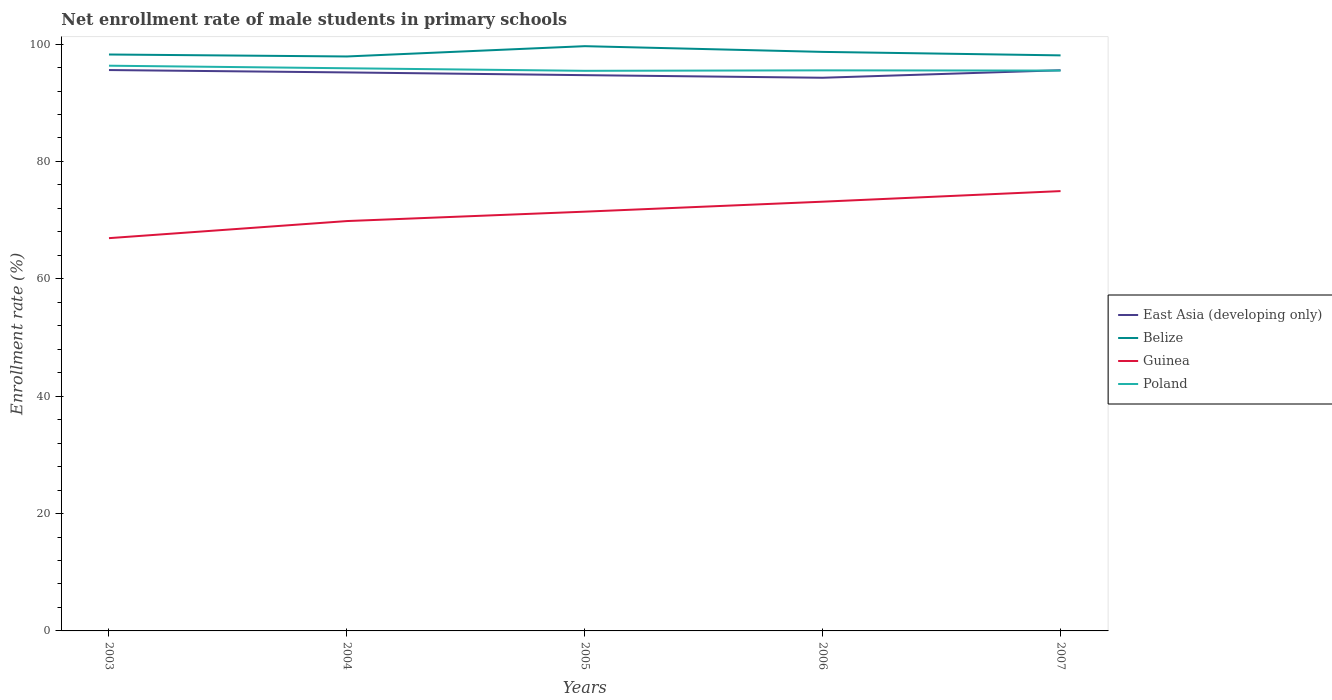How many different coloured lines are there?
Your answer should be compact. 4. Does the line corresponding to East Asia (developing only) intersect with the line corresponding to Poland?
Your answer should be compact. Yes. Is the number of lines equal to the number of legend labels?
Keep it short and to the point. Yes. Across all years, what is the maximum net enrollment rate of male students in primary schools in Poland?
Make the answer very short. 95.44. In which year was the net enrollment rate of male students in primary schools in Guinea maximum?
Keep it short and to the point. 2003. What is the total net enrollment rate of male students in primary schools in Poland in the graph?
Make the answer very short. 0.83. What is the difference between the highest and the second highest net enrollment rate of male students in primary schools in Belize?
Provide a succinct answer. 1.75. How many lines are there?
Provide a short and direct response. 4. What is the difference between two consecutive major ticks on the Y-axis?
Offer a terse response. 20. Does the graph contain any zero values?
Ensure brevity in your answer.  No. Does the graph contain grids?
Your response must be concise. No. How many legend labels are there?
Provide a short and direct response. 4. What is the title of the graph?
Give a very brief answer. Net enrollment rate of male students in primary schools. What is the label or title of the Y-axis?
Offer a terse response. Enrollment rate (%). What is the Enrollment rate (%) of East Asia (developing only) in 2003?
Offer a terse response. 95.57. What is the Enrollment rate (%) in Belize in 2003?
Offer a very short reply. 98.22. What is the Enrollment rate (%) of Guinea in 2003?
Your answer should be very brief. 66.93. What is the Enrollment rate (%) of Poland in 2003?
Provide a succinct answer. 96.31. What is the Enrollment rate (%) in East Asia (developing only) in 2004?
Provide a short and direct response. 95.17. What is the Enrollment rate (%) of Belize in 2004?
Give a very brief answer. 97.89. What is the Enrollment rate (%) of Guinea in 2004?
Provide a short and direct response. 69.84. What is the Enrollment rate (%) in Poland in 2004?
Provide a succinct answer. 95.88. What is the Enrollment rate (%) of East Asia (developing only) in 2005?
Offer a very short reply. 94.7. What is the Enrollment rate (%) in Belize in 2005?
Provide a succinct answer. 99.64. What is the Enrollment rate (%) in Guinea in 2005?
Give a very brief answer. 71.44. What is the Enrollment rate (%) of Poland in 2005?
Your answer should be compact. 95.44. What is the Enrollment rate (%) in East Asia (developing only) in 2006?
Provide a succinct answer. 94.26. What is the Enrollment rate (%) of Belize in 2006?
Your answer should be compact. 98.67. What is the Enrollment rate (%) of Guinea in 2006?
Offer a very short reply. 73.14. What is the Enrollment rate (%) of Poland in 2006?
Provide a succinct answer. 95.52. What is the Enrollment rate (%) of East Asia (developing only) in 2007?
Your answer should be very brief. 95.54. What is the Enrollment rate (%) in Belize in 2007?
Offer a terse response. 98.07. What is the Enrollment rate (%) in Guinea in 2007?
Provide a succinct answer. 74.94. What is the Enrollment rate (%) of Poland in 2007?
Your answer should be compact. 95.48. Across all years, what is the maximum Enrollment rate (%) in East Asia (developing only)?
Make the answer very short. 95.57. Across all years, what is the maximum Enrollment rate (%) of Belize?
Give a very brief answer. 99.64. Across all years, what is the maximum Enrollment rate (%) of Guinea?
Offer a terse response. 74.94. Across all years, what is the maximum Enrollment rate (%) in Poland?
Your response must be concise. 96.31. Across all years, what is the minimum Enrollment rate (%) in East Asia (developing only)?
Ensure brevity in your answer.  94.26. Across all years, what is the minimum Enrollment rate (%) of Belize?
Your response must be concise. 97.89. Across all years, what is the minimum Enrollment rate (%) of Guinea?
Keep it short and to the point. 66.93. Across all years, what is the minimum Enrollment rate (%) in Poland?
Keep it short and to the point. 95.44. What is the total Enrollment rate (%) in East Asia (developing only) in the graph?
Ensure brevity in your answer.  475.24. What is the total Enrollment rate (%) in Belize in the graph?
Offer a terse response. 492.49. What is the total Enrollment rate (%) of Guinea in the graph?
Provide a short and direct response. 356.3. What is the total Enrollment rate (%) in Poland in the graph?
Make the answer very short. 478.64. What is the difference between the Enrollment rate (%) in East Asia (developing only) in 2003 and that in 2004?
Provide a succinct answer. 0.41. What is the difference between the Enrollment rate (%) of Belize in 2003 and that in 2004?
Make the answer very short. 0.34. What is the difference between the Enrollment rate (%) in Guinea in 2003 and that in 2004?
Offer a terse response. -2.91. What is the difference between the Enrollment rate (%) of Poland in 2003 and that in 2004?
Your answer should be very brief. 0.44. What is the difference between the Enrollment rate (%) of East Asia (developing only) in 2003 and that in 2005?
Offer a very short reply. 0.87. What is the difference between the Enrollment rate (%) in Belize in 2003 and that in 2005?
Ensure brevity in your answer.  -1.42. What is the difference between the Enrollment rate (%) in Guinea in 2003 and that in 2005?
Your answer should be very brief. -4.51. What is the difference between the Enrollment rate (%) of Poland in 2003 and that in 2005?
Keep it short and to the point. 0.87. What is the difference between the Enrollment rate (%) of East Asia (developing only) in 2003 and that in 2006?
Provide a short and direct response. 1.31. What is the difference between the Enrollment rate (%) in Belize in 2003 and that in 2006?
Your response must be concise. -0.44. What is the difference between the Enrollment rate (%) of Guinea in 2003 and that in 2006?
Keep it short and to the point. -6.21. What is the difference between the Enrollment rate (%) of Poland in 2003 and that in 2006?
Provide a succinct answer. 0.79. What is the difference between the Enrollment rate (%) of East Asia (developing only) in 2003 and that in 2007?
Keep it short and to the point. 0.04. What is the difference between the Enrollment rate (%) in Belize in 2003 and that in 2007?
Make the answer very short. 0.15. What is the difference between the Enrollment rate (%) in Guinea in 2003 and that in 2007?
Offer a very short reply. -8.02. What is the difference between the Enrollment rate (%) in Poland in 2003 and that in 2007?
Offer a very short reply. 0.83. What is the difference between the Enrollment rate (%) in East Asia (developing only) in 2004 and that in 2005?
Keep it short and to the point. 0.47. What is the difference between the Enrollment rate (%) in Belize in 2004 and that in 2005?
Your answer should be compact. -1.75. What is the difference between the Enrollment rate (%) of Guinea in 2004 and that in 2005?
Your answer should be very brief. -1.6. What is the difference between the Enrollment rate (%) of Poland in 2004 and that in 2005?
Provide a short and direct response. 0.43. What is the difference between the Enrollment rate (%) in East Asia (developing only) in 2004 and that in 2006?
Provide a succinct answer. 0.91. What is the difference between the Enrollment rate (%) of Belize in 2004 and that in 2006?
Offer a very short reply. -0.78. What is the difference between the Enrollment rate (%) in Guinea in 2004 and that in 2006?
Offer a very short reply. -3.3. What is the difference between the Enrollment rate (%) in Poland in 2004 and that in 2006?
Provide a short and direct response. 0.36. What is the difference between the Enrollment rate (%) of East Asia (developing only) in 2004 and that in 2007?
Provide a succinct answer. -0.37. What is the difference between the Enrollment rate (%) in Belize in 2004 and that in 2007?
Offer a terse response. -0.18. What is the difference between the Enrollment rate (%) in Guinea in 2004 and that in 2007?
Offer a terse response. -5.11. What is the difference between the Enrollment rate (%) of Poland in 2004 and that in 2007?
Your answer should be very brief. 0.39. What is the difference between the Enrollment rate (%) of East Asia (developing only) in 2005 and that in 2006?
Offer a terse response. 0.44. What is the difference between the Enrollment rate (%) of Belize in 2005 and that in 2006?
Offer a very short reply. 0.97. What is the difference between the Enrollment rate (%) in Guinea in 2005 and that in 2006?
Give a very brief answer. -1.7. What is the difference between the Enrollment rate (%) of Poland in 2005 and that in 2006?
Your answer should be very brief. -0.08. What is the difference between the Enrollment rate (%) of East Asia (developing only) in 2005 and that in 2007?
Give a very brief answer. -0.84. What is the difference between the Enrollment rate (%) in Belize in 2005 and that in 2007?
Give a very brief answer. 1.57. What is the difference between the Enrollment rate (%) in Guinea in 2005 and that in 2007?
Provide a short and direct response. -3.5. What is the difference between the Enrollment rate (%) in Poland in 2005 and that in 2007?
Give a very brief answer. -0.04. What is the difference between the Enrollment rate (%) in East Asia (developing only) in 2006 and that in 2007?
Your answer should be compact. -1.28. What is the difference between the Enrollment rate (%) in Belize in 2006 and that in 2007?
Keep it short and to the point. 0.59. What is the difference between the Enrollment rate (%) of Guinea in 2006 and that in 2007?
Offer a terse response. -1.8. What is the difference between the Enrollment rate (%) in Poland in 2006 and that in 2007?
Offer a very short reply. 0.04. What is the difference between the Enrollment rate (%) of East Asia (developing only) in 2003 and the Enrollment rate (%) of Belize in 2004?
Offer a terse response. -2.31. What is the difference between the Enrollment rate (%) in East Asia (developing only) in 2003 and the Enrollment rate (%) in Guinea in 2004?
Your response must be concise. 25.73. What is the difference between the Enrollment rate (%) in East Asia (developing only) in 2003 and the Enrollment rate (%) in Poland in 2004?
Offer a very short reply. -0.3. What is the difference between the Enrollment rate (%) of Belize in 2003 and the Enrollment rate (%) of Guinea in 2004?
Give a very brief answer. 28.38. What is the difference between the Enrollment rate (%) of Belize in 2003 and the Enrollment rate (%) of Poland in 2004?
Provide a succinct answer. 2.35. What is the difference between the Enrollment rate (%) of Guinea in 2003 and the Enrollment rate (%) of Poland in 2004?
Your answer should be compact. -28.95. What is the difference between the Enrollment rate (%) in East Asia (developing only) in 2003 and the Enrollment rate (%) in Belize in 2005?
Your response must be concise. -4.07. What is the difference between the Enrollment rate (%) in East Asia (developing only) in 2003 and the Enrollment rate (%) in Guinea in 2005?
Your answer should be very brief. 24.13. What is the difference between the Enrollment rate (%) of East Asia (developing only) in 2003 and the Enrollment rate (%) of Poland in 2005?
Make the answer very short. 0.13. What is the difference between the Enrollment rate (%) of Belize in 2003 and the Enrollment rate (%) of Guinea in 2005?
Give a very brief answer. 26.78. What is the difference between the Enrollment rate (%) of Belize in 2003 and the Enrollment rate (%) of Poland in 2005?
Your answer should be very brief. 2.78. What is the difference between the Enrollment rate (%) of Guinea in 2003 and the Enrollment rate (%) of Poland in 2005?
Offer a very short reply. -28.51. What is the difference between the Enrollment rate (%) in East Asia (developing only) in 2003 and the Enrollment rate (%) in Belize in 2006?
Offer a very short reply. -3.09. What is the difference between the Enrollment rate (%) in East Asia (developing only) in 2003 and the Enrollment rate (%) in Guinea in 2006?
Offer a very short reply. 22.43. What is the difference between the Enrollment rate (%) of East Asia (developing only) in 2003 and the Enrollment rate (%) of Poland in 2006?
Your answer should be very brief. 0.05. What is the difference between the Enrollment rate (%) in Belize in 2003 and the Enrollment rate (%) in Guinea in 2006?
Your response must be concise. 25.08. What is the difference between the Enrollment rate (%) in Belize in 2003 and the Enrollment rate (%) in Poland in 2006?
Your answer should be very brief. 2.7. What is the difference between the Enrollment rate (%) of Guinea in 2003 and the Enrollment rate (%) of Poland in 2006?
Provide a succinct answer. -28.59. What is the difference between the Enrollment rate (%) in East Asia (developing only) in 2003 and the Enrollment rate (%) in Belize in 2007?
Provide a succinct answer. -2.5. What is the difference between the Enrollment rate (%) in East Asia (developing only) in 2003 and the Enrollment rate (%) in Guinea in 2007?
Keep it short and to the point. 20.63. What is the difference between the Enrollment rate (%) of East Asia (developing only) in 2003 and the Enrollment rate (%) of Poland in 2007?
Make the answer very short. 0.09. What is the difference between the Enrollment rate (%) of Belize in 2003 and the Enrollment rate (%) of Guinea in 2007?
Your answer should be compact. 23.28. What is the difference between the Enrollment rate (%) of Belize in 2003 and the Enrollment rate (%) of Poland in 2007?
Keep it short and to the point. 2.74. What is the difference between the Enrollment rate (%) in Guinea in 2003 and the Enrollment rate (%) in Poland in 2007?
Give a very brief answer. -28.56. What is the difference between the Enrollment rate (%) in East Asia (developing only) in 2004 and the Enrollment rate (%) in Belize in 2005?
Keep it short and to the point. -4.47. What is the difference between the Enrollment rate (%) of East Asia (developing only) in 2004 and the Enrollment rate (%) of Guinea in 2005?
Offer a terse response. 23.73. What is the difference between the Enrollment rate (%) of East Asia (developing only) in 2004 and the Enrollment rate (%) of Poland in 2005?
Provide a short and direct response. -0.27. What is the difference between the Enrollment rate (%) of Belize in 2004 and the Enrollment rate (%) of Guinea in 2005?
Provide a succinct answer. 26.45. What is the difference between the Enrollment rate (%) of Belize in 2004 and the Enrollment rate (%) of Poland in 2005?
Provide a short and direct response. 2.45. What is the difference between the Enrollment rate (%) in Guinea in 2004 and the Enrollment rate (%) in Poland in 2005?
Ensure brevity in your answer.  -25.6. What is the difference between the Enrollment rate (%) in East Asia (developing only) in 2004 and the Enrollment rate (%) in Belize in 2006?
Ensure brevity in your answer.  -3.5. What is the difference between the Enrollment rate (%) of East Asia (developing only) in 2004 and the Enrollment rate (%) of Guinea in 2006?
Provide a succinct answer. 22.03. What is the difference between the Enrollment rate (%) in East Asia (developing only) in 2004 and the Enrollment rate (%) in Poland in 2006?
Make the answer very short. -0.35. What is the difference between the Enrollment rate (%) in Belize in 2004 and the Enrollment rate (%) in Guinea in 2006?
Provide a short and direct response. 24.75. What is the difference between the Enrollment rate (%) in Belize in 2004 and the Enrollment rate (%) in Poland in 2006?
Your answer should be compact. 2.37. What is the difference between the Enrollment rate (%) of Guinea in 2004 and the Enrollment rate (%) of Poland in 2006?
Give a very brief answer. -25.68. What is the difference between the Enrollment rate (%) in East Asia (developing only) in 2004 and the Enrollment rate (%) in Belize in 2007?
Offer a terse response. -2.9. What is the difference between the Enrollment rate (%) in East Asia (developing only) in 2004 and the Enrollment rate (%) in Guinea in 2007?
Your answer should be compact. 20.22. What is the difference between the Enrollment rate (%) of East Asia (developing only) in 2004 and the Enrollment rate (%) of Poland in 2007?
Keep it short and to the point. -0.32. What is the difference between the Enrollment rate (%) of Belize in 2004 and the Enrollment rate (%) of Guinea in 2007?
Offer a very short reply. 22.94. What is the difference between the Enrollment rate (%) of Belize in 2004 and the Enrollment rate (%) of Poland in 2007?
Your response must be concise. 2.4. What is the difference between the Enrollment rate (%) of Guinea in 2004 and the Enrollment rate (%) of Poland in 2007?
Make the answer very short. -25.65. What is the difference between the Enrollment rate (%) in East Asia (developing only) in 2005 and the Enrollment rate (%) in Belize in 2006?
Make the answer very short. -3.96. What is the difference between the Enrollment rate (%) of East Asia (developing only) in 2005 and the Enrollment rate (%) of Guinea in 2006?
Provide a short and direct response. 21.56. What is the difference between the Enrollment rate (%) of East Asia (developing only) in 2005 and the Enrollment rate (%) of Poland in 2006?
Offer a very short reply. -0.82. What is the difference between the Enrollment rate (%) in Belize in 2005 and the Enrollment rate (%) in Guinea in 2006?
Ensure brevity in your answer.  26.5. What is the difference between the Enrollment rate (%) of Belize in 2005 and the Enrollment rate (%) of Poland in 2006?
Offer a very short reply. 4.12. What is the difference between the Enrollment rate (%) in Guinea in 2005 and the Enrollment rate (%) in Poland in 2006?
Make the answer very short. -24.08. What is the difference between the Enrollment rate (%) in East Asia (developing only) in 2005 and the Enrollment rate (%) in Belize in 2007?
Ensure brevity in your answer.  -3.37. What is the difference between the Enrollment rate (%) of East Asia (developing only) in 2005 and the Enrollment rate (%) of Guinea in 2007?
Give a very brief answer. 19.76. What is the difference between the Enrollment rate (%) of East Asia (developing only) in 2005 and the Enrollment rate (%) of Poland in 2007?
Give a very brief answer. -0.78. What is the difference between the Enrollment rate (%) of Belize in 2005 and the Enrollment rate (%) of Guinea in 2007?
Offer a terse response. 24.7. What is the difference between the Enrollment rate (%) of Belize in 2005 and the Enrollment rate (%) of Poland in 2007?
Offer a very short reply. 4.16. What is the difference between the Enrollment rate (%) of Guinea in 2005 and the Enrollment rate (%) of Poland in 2007?
Your answer should be very brief. -24.04. What is the difference between the Enrollment rate (%) in East Asia (developing only) in 2006 and the Enrollment rate (%) in Belize in 2007?
Offer a terse response. -3.81. What is the difference between the Enrollment rate (%) of East Asia (developing only) in 2006 and the Enrollment rate (%) of Guinea in 2007?
Give a very brief answer. 19.32. What is the difference between the Enrollment rate (%) of East Asia (developing only) in 2006 and the Enrollment rate (%) of Poland in 2007?
Ensure brevity in your answer.  -1.22. What is the difference between the Enrollment rate (%) of Belize in 2006 and the Enrollment rate (%) of Guinea in 2007?
Your answer should be very brief. 23.72. What is the difference between the Enrollment rate (%) of Belize in 2006 and the Enrollment rate (%) of Poland in 2007?
Your answer should be very brief. 3.18. What is the difference between the Enrollment rate (%) of Guinea in 2006 and the Enrollment rate (%) of Poland in 2007?
Your answer should be very brief. -22.34. What is the average Enrollment rate (%) of East Asia (developing only) per year?
Your answer should be very brief. 95.05. What is the average Enrollment rate (%) in Belize per year?
Make the answer very short. 98.5. What is the average Enrollment rate (%) of Guinea per year?
Provide a short and direct response. 71.26. What is the average Enrollment rate (%) in Poland per year?
Offer a very short reply. 95.73. In the year 2003, what is the difference between the Enrollment rate (%) of East Asia (developing only) and Enrollment rate (%) of Belize?
Offer a terse response. -2.65. In the year 2003, what is the difference between the Enrollment rate (%) in East Asia (developing only) and Enrollment rate (%) in Guinea?
Your answer should be very brief. 28.64. In the year 2003, what is the difference between the Enrollment rate (%) of East Asia (developing only) and Enrollment rate (%) of Poland?
Keep it short and to the point. -0.74. In the year 2003, what is the difference between the Enrollment rate (%) in Belize and Enrollment rate (%) in Guinea?
Your answer should be very brief. 31.29. In the year 2003, what is the difference between the Enrollment rate (%) in Belize and Enrollment rate (%) in Poland?
Keep it short and to the point. 1.91. In the year 2003, what is the difference between the Enrollment rate (%) of Guinea and Enrollment rate (%) of Poland?
Make the answer very short. -29.39. In the year 2004, what is the difference between the Enrollment rate (%) of East Asia (developing only) and Enrollment rate (%) of Belize?
Ensure brevity in your answer.  -2.72. In the year 2004, what is the difference between the Enrollment rate (%) in East Asia (developing only) and Enrollment rate (%) in Guinea?
Keep it short and to the point. 25.33. In the year 2004, what is the difference between the Enrollment rate (%) of East Asia (developing only) and Enrollment rate (%) of Poland?
Give a very brief answer. -0.71. In the year 2004, what is the difference between the Enrollment rate (%) in Belize and Enrollment rate (%) in Guinea?
Offer a very short reply. 28.05. In the year 2004, what is the difference between the Enrollment rate (%) in Belize and Enrollment rate (%) in Poland?
Offer a very short reply. 2.01. In the year 2004, what is the difference between the Enrollment rate (%) of Guinea and Enrollment rate (%) of Poland?
Your answer should be compact. -26.04. In the year 2005, what is the difference between the Enrollment rate (%) of East Asia (developing only) and Enrollment rate (%) of Belize?
Your response must be concise. -4.94. In the year 2005, what is the difference between the Enrollment rate (%) in East Asia (developing only) and Enrollment rate (%) in Guinea?
Make the answer very short. 23.26. In the year 2005, what is the difference between the Enrollment rate (%) of East Asia (developing only) and Enrollment rate (%) of Poland?
Make the answer very short. -0.74. In the year 2005, what is the difference between the Enrollment rate (%) in Belize and Enrollment rate (%) in Guinea?
Your response must be concise. 28.2. In the year 2005, what is the difference between the Enrollment rate (%) of Belize and Enrollment rate (%) of Poland?
Your answer should be very brief. 4.2. In the year 2005, what is the difference between the Enrollment rate (%) in Guinea and Enrollment rate (%) in Poland?
Keep it short and to the point. -24. In the year 2006, what is the difference between the Enrollment rate (%) in East Asia (developing only) and Enrollment rate (%) in Belize?
Ensure brevity in your answer.  -4.4. In the year 2006, what is the difference between the Enrollment rate (%) in East Asia (developing only) and Enrollment rate (%) in Guinea?
Your response must be concise. 21.12. In the year 2006, what is the difference between the Enrollment rate (%) in East Asia (developing only) and Enrollment rate (%) in Poland?
Give a very brief answer. -1.26. In the year 2006, what is the difference between the Enrollment rate (%) of Belize and Enrollment rate (%) of Guinea?
Ensure brevity in your answer.  25.52. In the year 2006, what is the difference between the Enrollment rate (%) of Belize and Enrollment rate (%) of Poland?
Your answer should be compact. 3.15. In the year 2006, what is the difference between the Enrollment rate (%) of Guinea and Enrollment rate (%) of Poland?
Offer a terse response. -22.38. In the year 2007, what is the difference between the Enrollment rate (%) in East Asia (developing only) and Enrollment rate (%) in Belize?
Offer a very short reply. -2.53. In the year 2007, what is the difference between the Enrollment rate (%) of East Asia (developing only) and Enrollment rate (%) of Guinea?
Offer a terse response. 20.59. In the year 2007, what is the difference between the Enrollment rate (%) of East Asia (developing only) and Enrollment rate (%) of Poland?
Your answer should be very brief. 0.05. In the year 2007, what is the difference between the Enrollment rate (%) in Belize and Enrollment rate (%) in Guinea?
Keep it short and to the point. 23.13. In the year 2007, what is the difference between the Enrollment rate (%) in Belize and Enrollment rate (%) in Poland?
Make the answer very short. 2.59. In the year 2007, what is the difference between the Enrollment rate (%) in Guinea and Enrollment rate (%) in Poland?
Provide a short and direct response. -20.54. What is the ratio of the Enrollment rate (%) in East Asia (developing only) in 2003 to that in 2004?
Provide a short and direct response. 1. What is the ratio of the Enrollment rate (%) of Belize in 2003 to that in 2004?
Offer a very short reply. 1. What is the ratio of the Enrollment rate (%) of Guinea in 2003 to that in 2004?
Offer a terse response. 0.96. What is the ratio of the Enrollment rate (%) in Poland in 2003 to that in 2004?
Offer a terse response. 1. What is the ratio of the Enrollment rate (%) of East Asia (developing only) in 2003 to that in 2005?
Offer a very short reply. 1.01. What is the ratio of the Enrollment rate (%) of Belize in 2003 to that in 2005?
Ensure brevity in your answer.  0.99. What is the ratio of the Enrollment rate (%) in Guinea in 2003 to that in 2005?
Your answer should be very brief. 0.94. What is the ratio of the Enrollment rate (%) of Poland in 2003 to that in 2005?
Your answer should be very brief. 1.01. What is the ratio of the Enrollment rate (%) in East Asia (developing only) in 2003 to that in 2006?
Make the answer very short. 1.01. What is the ratio of the Enrollment rate (%) of Guinea in 2003 to that in 2006?
Your answer should be compact. 0.92. What is the ratio of the Enrollment rate (%) in Poland in 2003 to that in 2006?
Ensure brevity in your answer.  1.01. What is the ratio of the Enrollment rate (%) in Guinea in 2003 to that in 2007?
Offer a terse response. 0.89. What is the ratio of the Enrollment rate (%) of Poland in 2003 to that in 2007?
Offer a very short reply. 1.01. What is the ratio of the Enrollment rate (%) in Belize in 2004 to that in 2005?
Keep it short and to the point. 0.98. What is the ratio of the Enrollment rate (%) of Guinea in 2004 to that in 2005?
Your answer should be compact. 0.98. What is the ratio of the Enrollment rate (%) in Poland in 2004 to that in 2005?
Your answer should be compact. 1. What is the ratio of the Enrollment rate (%) of East Asia (developing only) in 2004 to that in 2006?
Keep it short and to the point. 1.01. What is the ratio of the Enrollment rate (%) in Belize in 2004 to that in 2006?
Provide a short and direct response. 0.99. What is the ratio of the Enrollment rate (%) of Guinea in 2004 to that in 2006?
Your answer should be very brief. 0.95. What is the ratio of the Enrollment rate (%) in Poland in 2004 to that in 2006?
Your answer should be compact. 1. What is the ratio of the Enrollment rate (%) in East Asia (developing only) in 2004 to that in 2007?
Provide a short and direct response. 1. What is the ratio of the Enrollment rate (%) in Guinea in 2004 to that in 2007?
Your answer should be compact. 0.93. What is the ratio of the Enrollment rate (%) in Poland in 2004 to that in 2007?
Your answer should be compact. 1. What is the ratio of the Enrollment rate (%) in Belize in 2005 to that in 2006?
Provide a short and direct response. 1.01. What is the ratio of the Enrollment rate (%) in Guinea in 2005 to that in 2006?
Offer a very short reply. 0.98. What is the ratio of the Enrollment rate (%) of Belize in 2005 to that in 2007?
Provide a short and direct response. 1.02. What is the ratio of the Enrollment rate (%) of Guinea in 2005 to that in 2007?
Give a very brief answer. 0.95. What is the ratio of the Enrollment rate (%) in East Asia (developing only) in 2006 to that in 2007?
Give a very brief answer. 0.99. What is the ratio of the Enrollment rate (%) of Guinea in 2006 to that in 2007?
Provide a short and direct response. 0.98. What is the difference between the highest and the second highest Enrollment rate (%) in East Asia (developing only)?
Provide a short and direct response. 0.04. What is the difference between the highest and the second highest Enrollment rate (%) of Belize?
Your answer should be very brief. 0.97. What is the difference between the highest and the second highest Enrollment rate (%) in Guinea?
Give a very brief answer. 1.8. What is the difference between the highest and the second highest Enrollment rate (%) of Poland?
Your answer should be compact. 0.44. What is the difference between the highest and the lowest Enrollment rate (%) of East Asia (developing only)?
Your answer should be compact. 1.31. What is the difference between the highest and the lowest Enrollment rate (%) of Belize?
Offer a very short reply. 1.75. What is the difference between the highest and the lowest Enrollment rate (%) in Guinea?
Provide a short and direct response. 8.02. What is the difference between the highest and the lowest Enrollment rate (%) of Poland?
Your answer should be very brief. 0.87. 